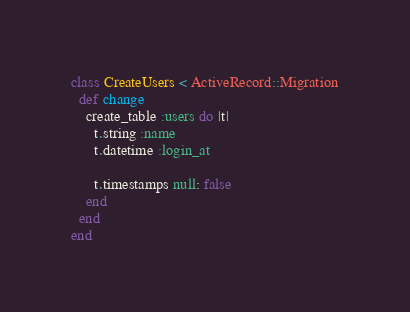Convert code to text. <code><loc_0><loc_0><loc_500><loc_500><_Ruby_>class CreateUsers < ActiveRecord::Migration
  def change
    create_table :users do |t|
      t.string :name
      t.datetime :login_at

      t.timestamps null: false
    end
  end
end
</code> 